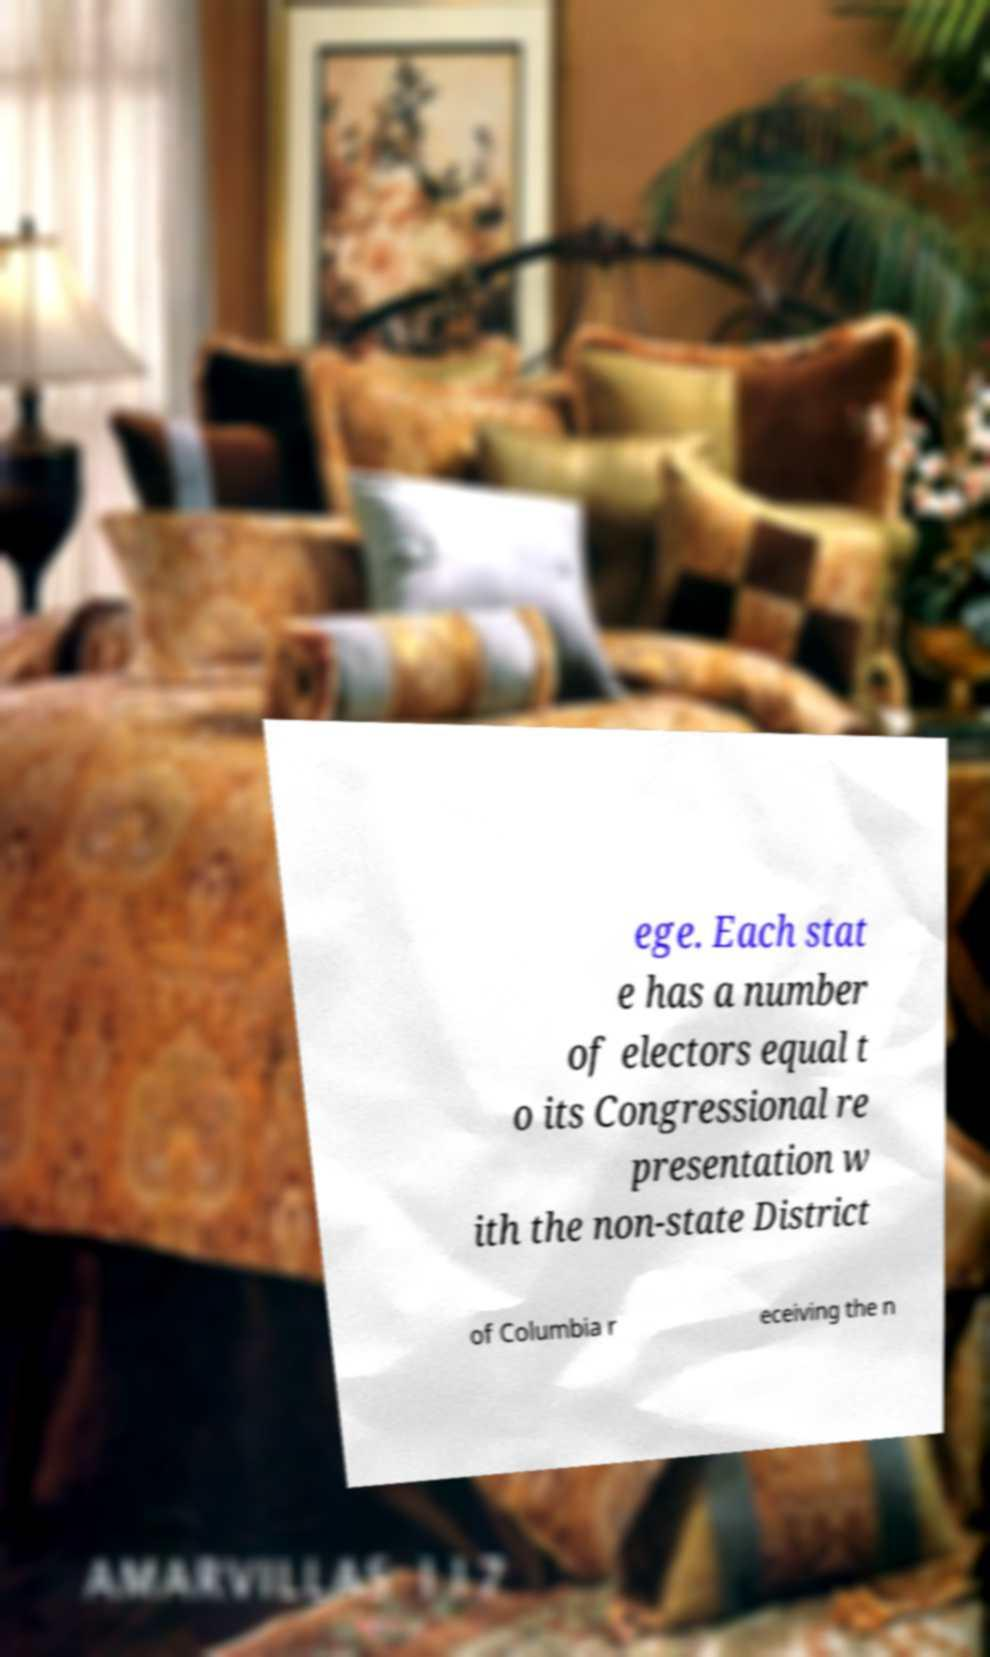I need the written content from this picture converted into text. Can you do that? ege. Each stat e has a number of electors equal t o its Congressional re presentation w ith the non-state District of Columbia r eceiving the n 